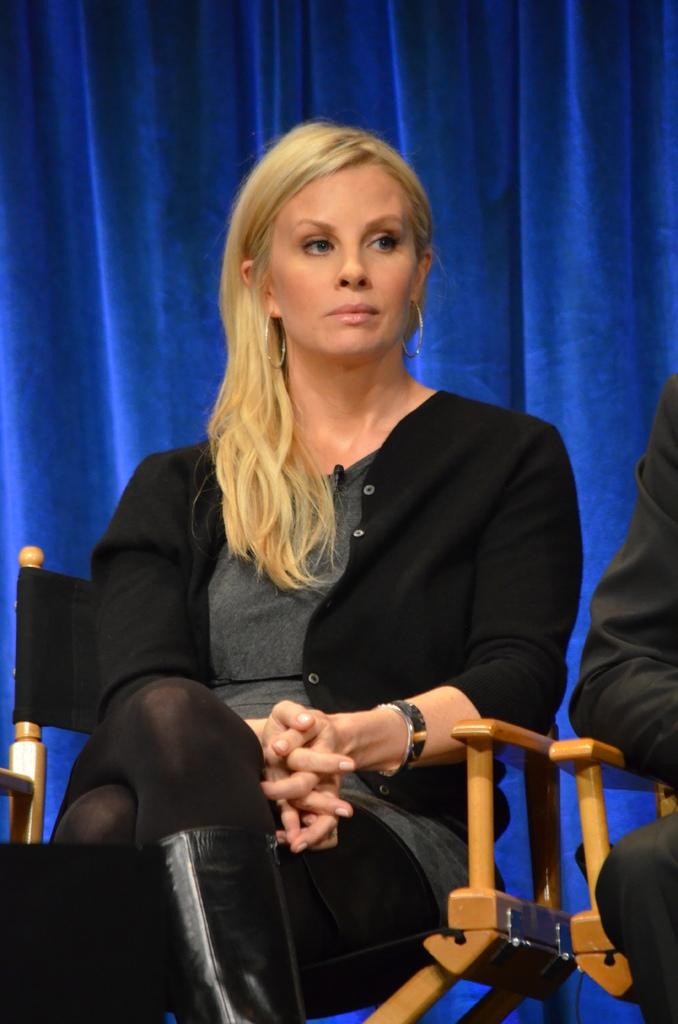What are the people in the image doing? The people in the image are sitting on chairs. Can you describe the object in the bottom left corner of the image? Unfortunately, the provided facts do not give any information about the object in the bottom left corner. What can be seen in the background of the image? There is cloth visible in the background of the image. What type of quartz can be seen on the chair in the image? There is no quartz present in the image. How does the wren interact with the people sitting on chairs in the image? There is no wren present in the image. 